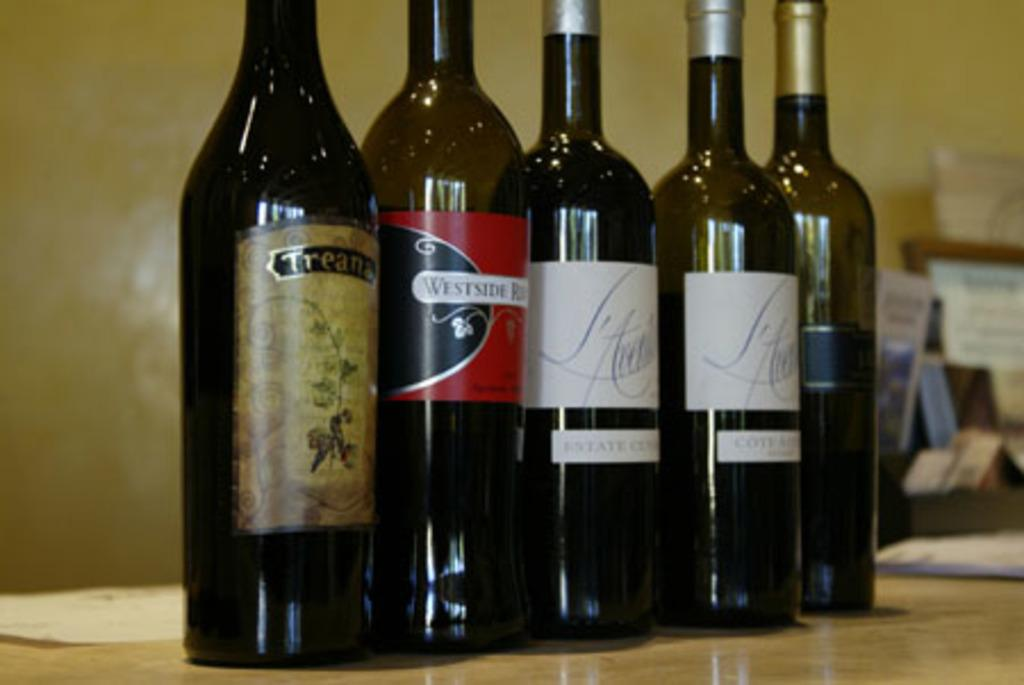<image>
Write a terse but informative summary of the picture. A row of wine bottles are on a table and one of them says Treans. 